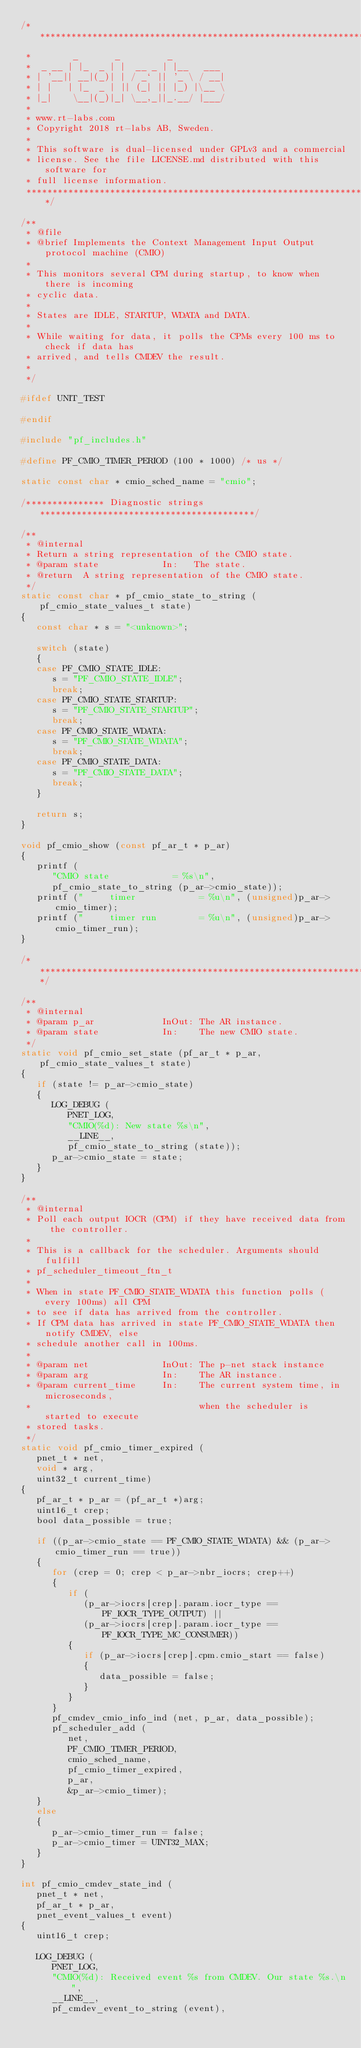<code> <loc_0><loc_0><loc_500><loc_500><_C_>/*********************************************************************
 *        _       _         _
 *  _ __ | |_  _ | |  __ _ | |__   ___
 * | '__|| __|(_)| | / _` || '_ \ / __|
 * | |   | |_  _ | || (_| || |_) |\__ \
 * |_|    \__|(_)|_| \__,_||_.__/ |___/
 *
 * www.rt-labs.com
 * Copyright 2018 rt-labs AB, Sweden.
 *
 * This software is dual-licensed under GPLv3 and a commercial
 * license. See the file LICENSE.md distributed with this software for
 * full license information.
 ********************************************************************/

/**
 * @file
 * @brief Implements the Context Management Input Output protocol machine (CMIO)
 *
 * This monitors several CPM during startup, to know when there is incoming
 * cyclic data.
 *
 * States are IDLE, STARTUP, WDATA and DATA.
 *
 * While waiting for data, it polls the CPMs every 100 ms to check if data has
 * arrived, and tells CMDEV the result.
 *
 */

#ifdef UNIT_TEST

#endif

#include "pf_includes.h"

#define PF_CMIO_TIMER_PERIOD (100 * 1000) /* us */

static const char * cmio_sched_name = "cmio";

/*************** Diagnostic strings *****************************************/

/**
 * @internal
 * Return a string representation of the CMIO state.
 * @param state            In:   The state.
 * @return  A string representation of the CMIO state.
 */
static const char * pf_cmio_state_to_string (pf_cmio_state_values_t state)
{
   const char * s = "<unknown>";

   switch (state)
   {
   case PF_CMIO_STATE_IDLE:
      s = "PF_CMIO_STATE_IDLE";
      break;
   case PF_CMIO_STATE_STARTUP:
      s = "PF_CMIO_STATE_STARTUP";
      break;
   case PF_CMIO_STATE_WDATA:
      s = "PF_CMIO_STATE_WDATA";
      break;
   case PF_CMIO_STATE_DATA:
      s = "PF_CMIO_STATE_DATA";
      break;
   }

   return s;
}

void pf_cmio_show (const pf_ar_t * p_ar)
{
   printf (
      "CMIO state            = %s\n",
      pf_cmio_state_to_string (p_ar->cmio_state));
   printf ("     timer            = %u\n", (unsigned)p_ar->cmio_timer);
   printf ("     timer run        = %u\n", (unsigned)p_ar->cmio_timer_run);
}

/****************************************************************************/

/**
 * @internal
 * @param p_ar             InOut: The AR instance.
 * @param state            In:    The new CMIO state.
 */
static void pf_cmio_set_state (pf_ar_t * p_ar, pf_cmio_state_values_t state)
{
   if (state != p_ar->cmio_state)
   {
      LOG_DEBUG (
         PNET_LOG,
         "CMIO(%d): New state %s\n",
         __LINE__,
         pf_cmio_state_to_string (state));
      p_ar->cmio_state = state;
   }
}

/**
 * @internal
 * Poll each output IOCR (CPM) if they have received data from the controller.
 *
 * This is a callback for the scheduler. Arguments should fulfill
 * pf_scheduler_timeout_ftn_t
 *
 * When in state PF_CMIO_STATE_WDATA this function polls (every 100ms) all CPM
 * to see if data has arrived from the controller.
 * If CPM data has arrived in state PF_CMIO_STATE_WDATA then notify CMDEV, else
 * schedule another call in 100ms.
 *
 * @param net              InOut: The p-net stack instance
 * @param arg              In:    The AR instance.
 * @param current_time     In:    The current system time, in microseconds,
 *                                when the scheduler is started to execute
 * stored tasks.
 */
static void pf_cmio_timer_expired (
   pnet_t * net,
   void * arg,
   uint32_t current_time)
{
   pf_ar_t * p_ar = (pf_ar_t *)arg;
   uint16_t crep;
   bool data_possible = true;

   if ((p_ar->cmio_state == PF_CMIO_STATE_WDATA) && (p_ar->cmio_timer_run == true))
   {
      for (crep = 0; crep < p_ar->nbr_iocrs; crep++)
      {
         if (
            (p_ar->iocrs[crep].param.iocr_type == PF_IOCR_TYPE_OUTPUT) ||
            (p_ar->iocrs[crep].param.iocr_type == PF_IOCR_TYPE_MC_CONSUMER))
         {
            if (p_ar->iocrs[crep].cpm.cmio_start == false)
            {
               data_possible = false;
            }
         }
      }
      pf_cmdev_cmio_info_ind (net, p_ar, data_possible);
      pf_scheduler_add (
         net,
         PF_CMIO_TIMER_PERIOD,
         cmio_sched_name,
         pf_cmio_timer_expired,
         p_ar,
         &p_ar->cmio_timer);
   }
   else
   {
      p_ar->cmio_timer_run = false;
      p_ar->cmio_timer = UINT32_MAX;
   }
}

int pf_cmio_cmdev_state_ind (
   pnet_t * net,
   pf_ar_t * p_ar,
   pnet_event_values_t event)
{
   uint16_t crep;

   LOG_DEBUG (
      PNET_LOG,
      "CMIO(%d): Received event %s from CMDEV. Our state %s.\n",
      __LINE__,
      pf_cmdev_event_to_string (event),</code> 